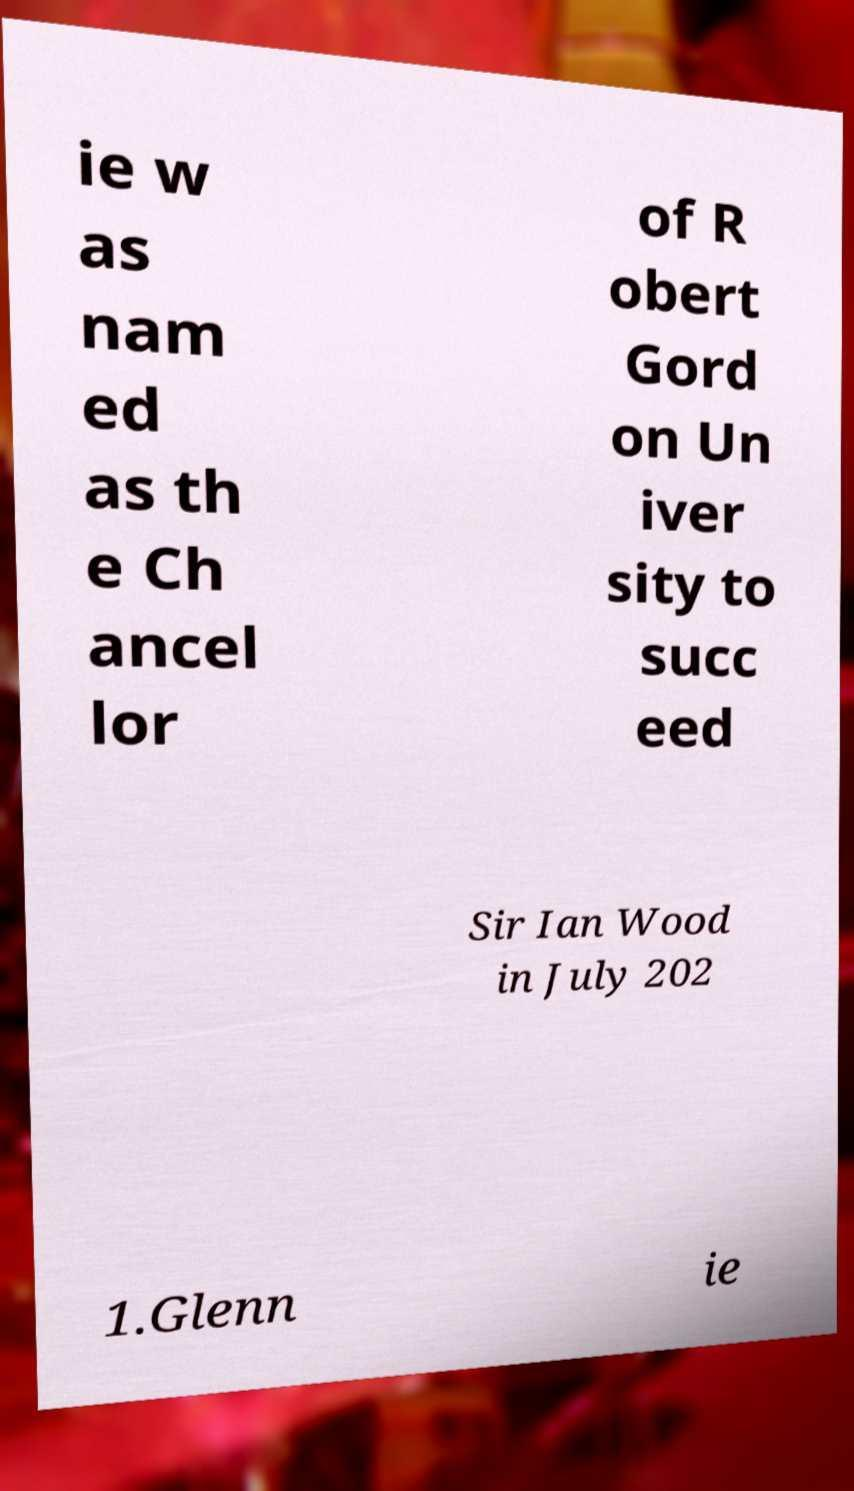What messages or text are displayed in this image? I need them in a readable, typed format. ie w as nam ed as th e Ch ancel lor of R obert Gord on Un iver sity to succ eed Sir Ian Wood in July 202 1.Glenn ie 